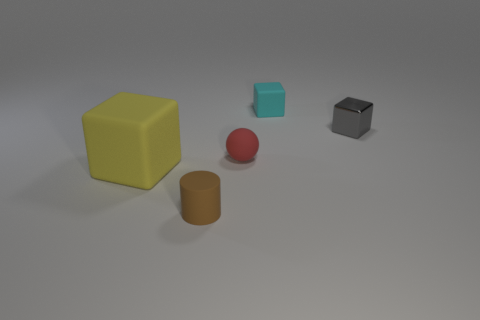Add 5 brown matte objects. How many objects exist? 10 Subtract all blocks. How many objects are left? 2 Subtract 0 cyan cylinders. How many objects are left? 5 Subtract all brown cylinders. Subtract all cyan metal spheres. How many objects are left? 4 Add 4 large yellow blocks. How many large yellow blocks are left? 5 Add 1 red metal balls. How many red metal balls exist? 1 